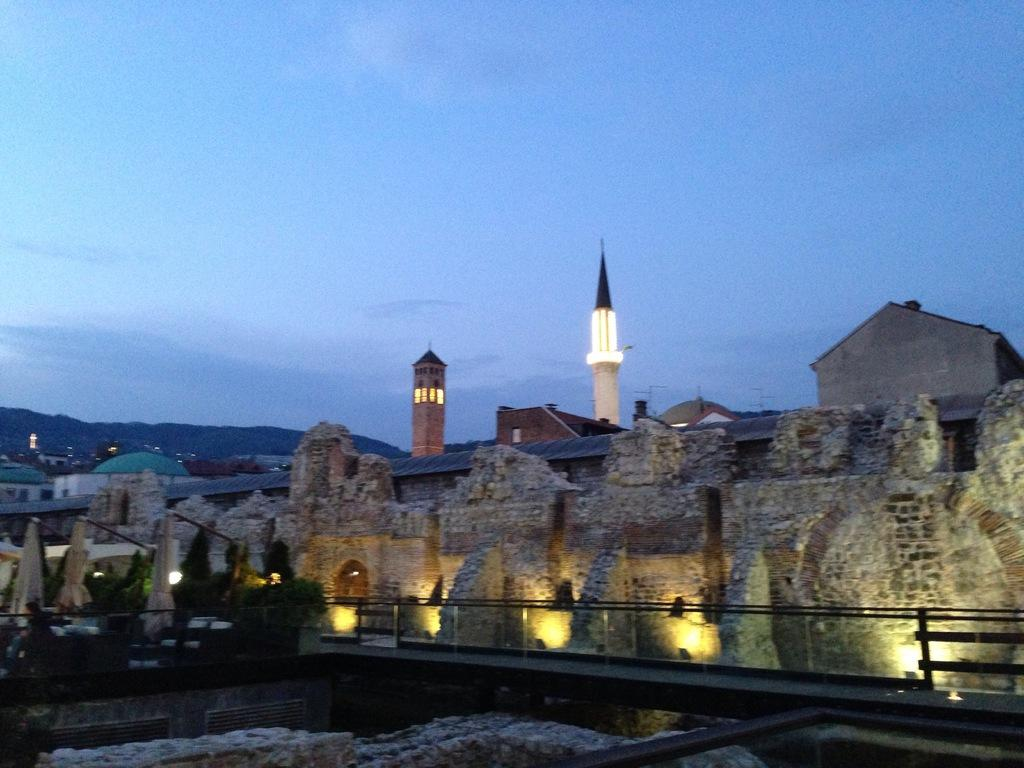What type of structures can be seen in the image? There are buildings in the image. What else is visible in the image besides the buildings? There are lights and trees visible in the image. What can be seen in the background of the image? The sky is visible in the background of the image. What country's history is depicted in the image? The image does not depict any specific country's history; it features buildings, lights, trees, and the sky. Can you tell me how many basketball players are visible in the image? There are no basketball players present in the image. 